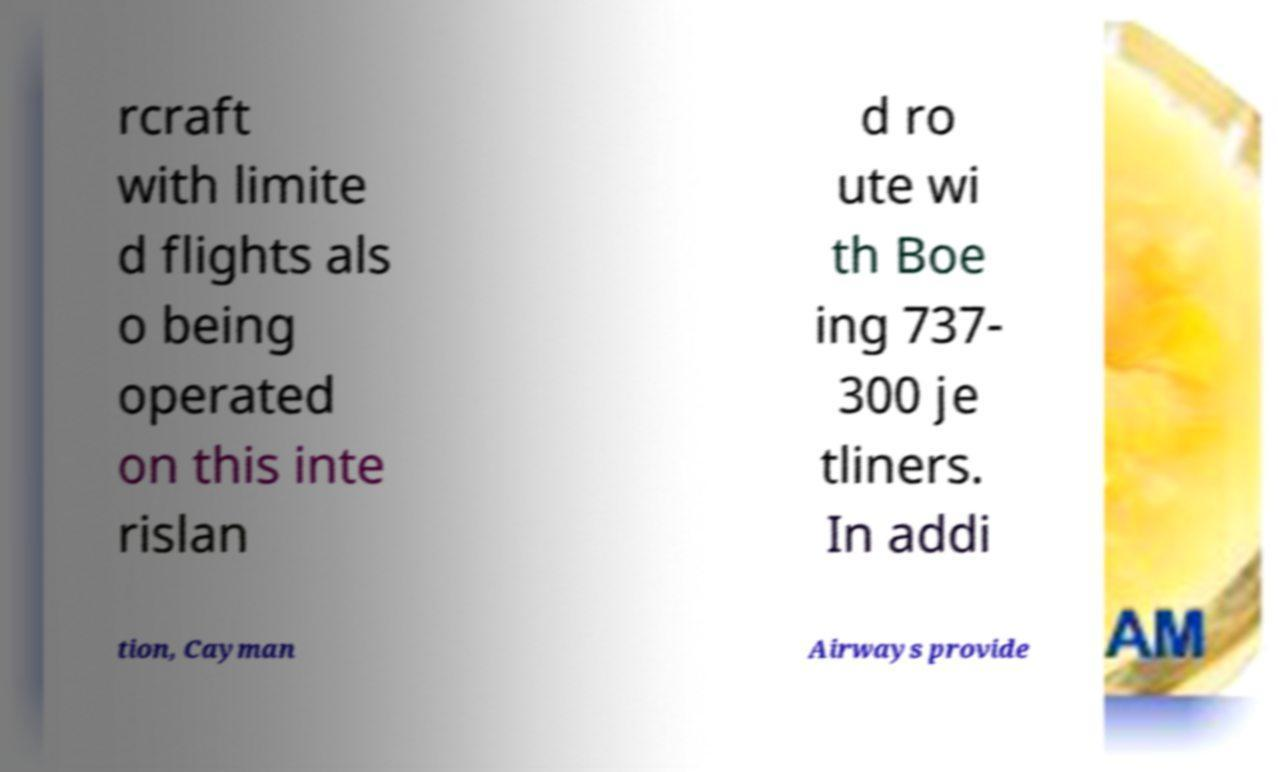Please identify and transcribe the text found in this image. rcraft with limite d flights als o being operated on this inte rislan d ro ute wi th Boe ing 737- 300 je tliners. In addi tion, Cayman Airways provide 